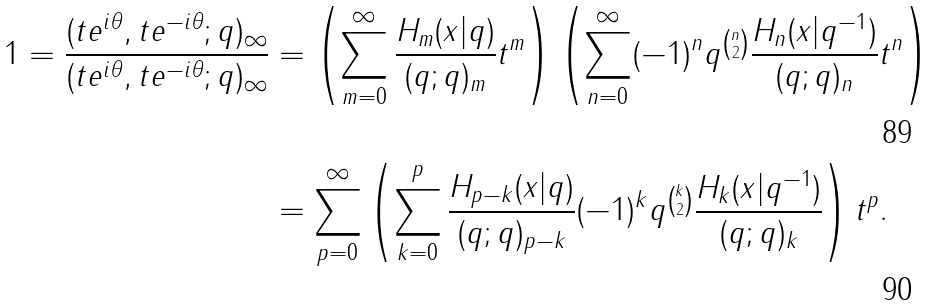<formula> <loc_0><loc_0><loc_500><loc_500>1 = \frac { ( t e ^ { i \theta } , t e ^ { - i \theta } ; q ) _ { \infty } } { ( t e ^ { i \theta } , t e ^ { - i \theta } ; q ) _ { \infty } } & = \left ( \sum _ { m = 0 } ^ { \infty } \frac { H _ { m } ( x | q ) } { ( q ; q ) _ { m } } t ^ { m } \right ) \left ( \sum _ { n = 0 } ^ { \infty } ( - 1 ) ^ { n } q ^ { \binom { n } { 2 } } \frac { H _ { n } ( x | q ^ { - 1 } ) } { ( q ; q ) _ { n } } t ^ { n } \right ) \\ & = \sum _ { p = 0 } ^ { \infty } \left ( \sum _ { k = 0 } ^ { p } \frac { H _ { p - k } ( x | q ) } { ( q ; q ) _ { p - k } } ( - 1 ) ^ { k } q ^ { \binom { k } { 2 } } \frac { H _ { k } ( x | q ^ { - 1 } ) } { ( q ; q ) _ { k } } \right ) t ^ { p } .</formula> 